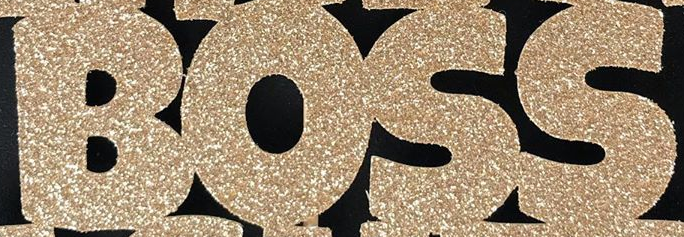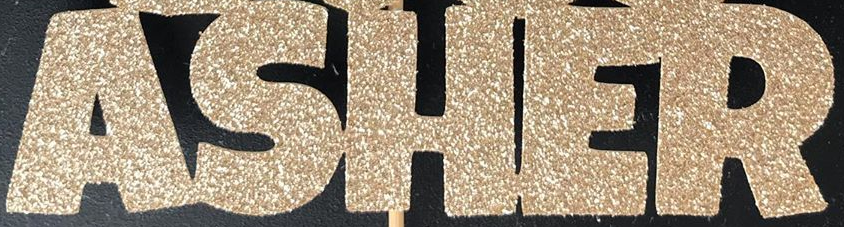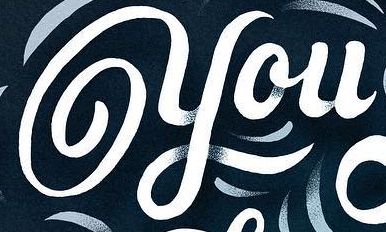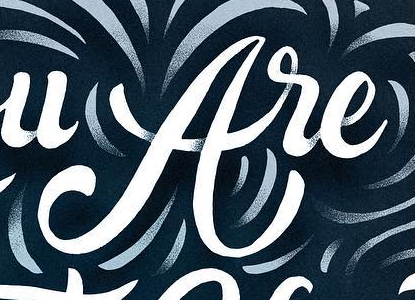Transcribe the words shown in these images in order, separated by a semicolon. BOSS; ASHER; you; are 